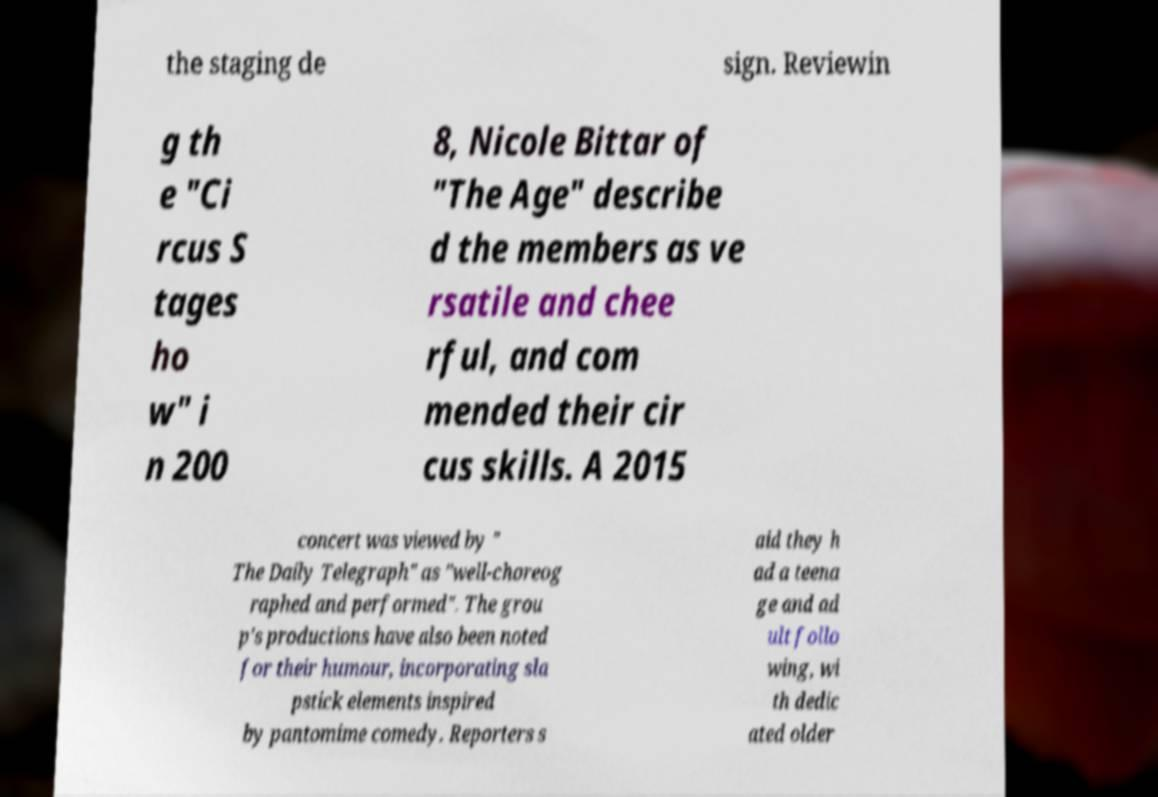What messages or text are displayed in this image? I need them in a readable, typed format. the staging de sign. Reviewin g th e "Ci rcus S tages ho w" i n 200 8, Nicole Bittar of "The Age" describe d the members as ve rsatile and chee rful, and com mended their cir cus skills. A 2015 concert was viewed by " The Daily Telegraph" as "well-choreog raphed and performed". The grou p's productions have also been noted for their humour, incorporating sla pstick elements inspired by pantomime comedy. Reporters s aid they h ad a teena ge and ad ult follo wing, wi th dedic ated older 